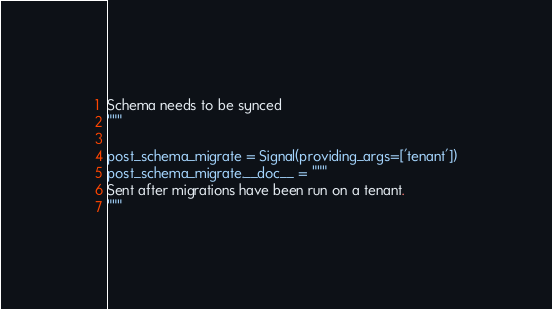Convert code to text. <code><loc_0><loc_0><loc_500><loc_500><_Python_>Schema needs to be synced
"""

post_schema_migrate = Signal(providing_args=['tenant'])
post_schema_migrate.__doc__ = """
Sent after migrations have been run on a tenant.
"""
</code> 